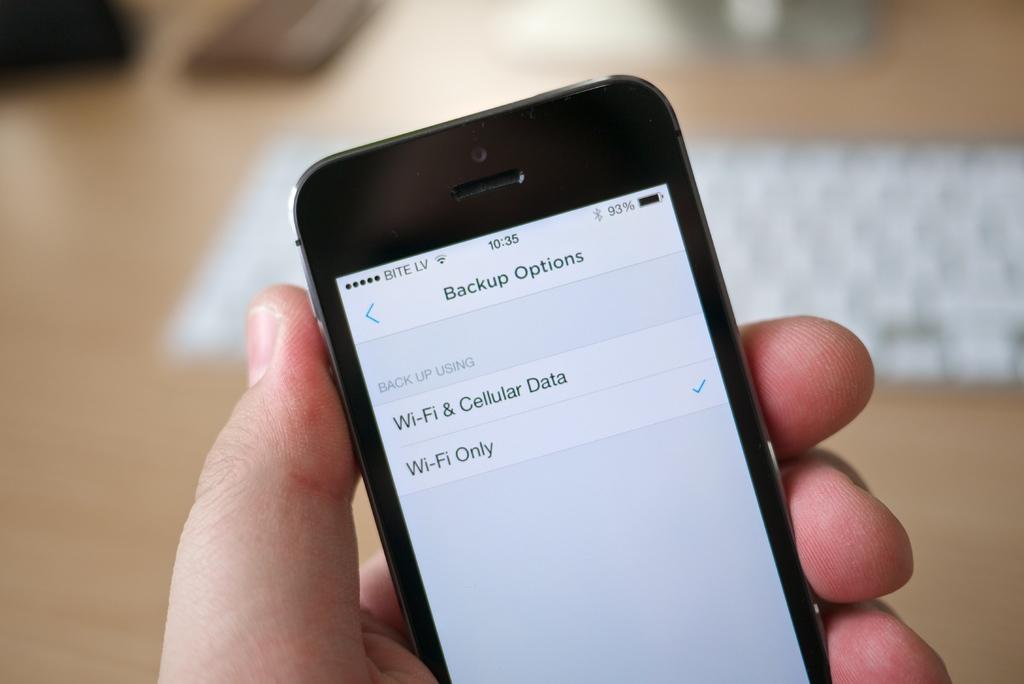What options is this screen ment for?
Make the answer very short. Backup. What option did this person select?
Make the answer very short. Wi-fi only. 